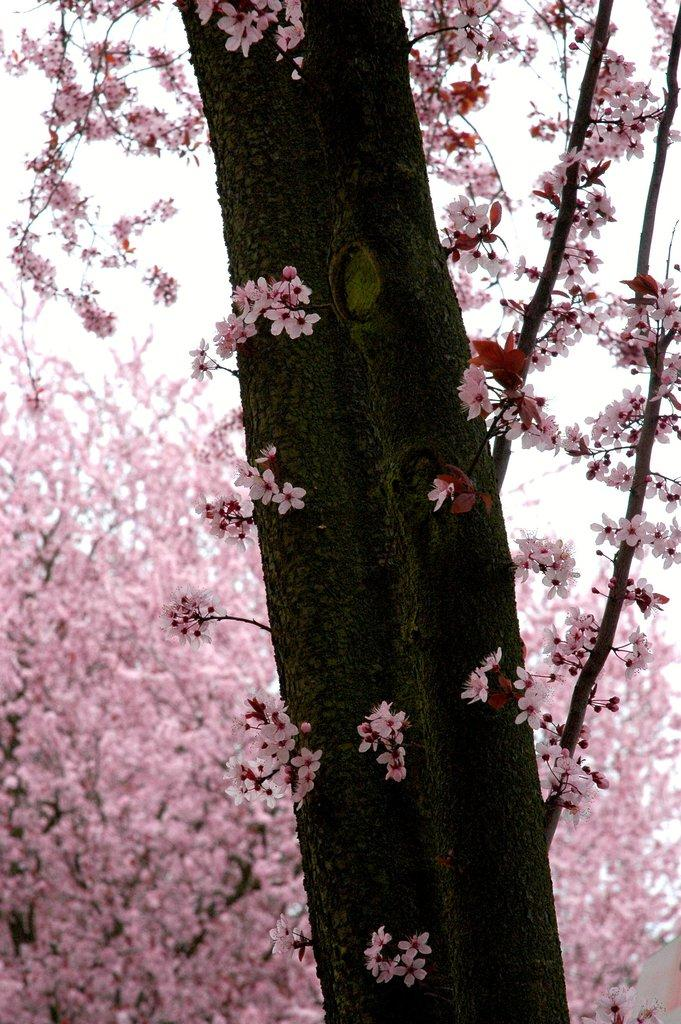What type of trees are present in the image? There are cherry blossom trees in the image. What color are the flowers on the cherry blossom trees? The flowers on the cherry blossom trees are pink. What is visible at the top of the image? The sky is visible at the top of the image. What type of hammer is hanging from the cherry blossom tree in the image? There is no hammer present in the image; it features cherry blossom trees with pink flowers and a visible sky. What is the condition of the twig on the cherry blossom tree in the image? There is no twig mentioned in the image, as it only describes the trees and their flowers. 